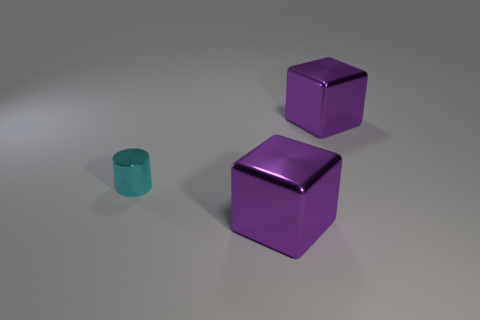Are there any other things that are the same size as the shiny cylinder?
Make the answer very short. No. There is a cube in front of the large purple shiny cube right of the purple metal thing in front of the small object; how big is it?
Offer a very short reply. Large. There is a tiny cyan metallic thing; is its shape the same as the large purple thing behind the metal cylinder?
Provide a short and direct response. No. Are there any small things of the same color as the tiny shiny cylinder?
Your answer should be very brief. No. How many cubes are big metal objects or small cyan objects?
Your answer should be very brief. 2. Are there any other cyan metal objects of the same shape as the small thing?
Make the answer very short. No. How many other objects are there of the same color as the small metallic thing?
Make the answer very short. 0. Are there fewer small metal cylinders behind the small cyan metal cylinder than big metallic objects?
Give a very brief answer. Yes. What number of big metallic balls are there?
Provide a succinct answer. 0. How many large purple blocks are the same material as the tiny cyan thing?
Make the answer very short. 2. 